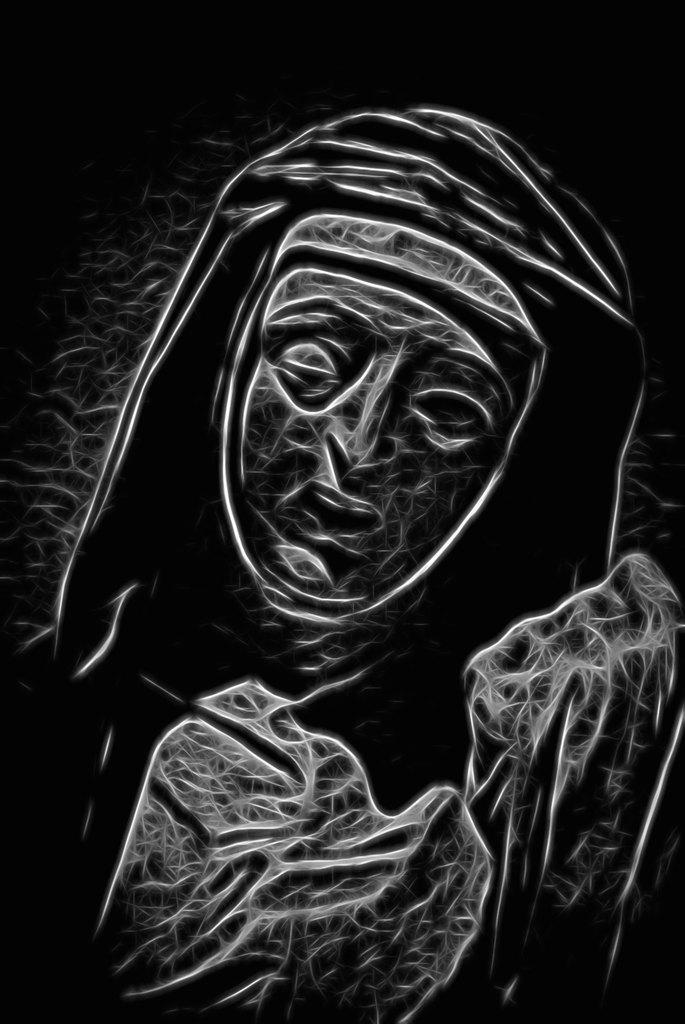Could you give a brief overview of what you see in this image? In this image, we can see a painting of a person. In the background, we can see black color. 